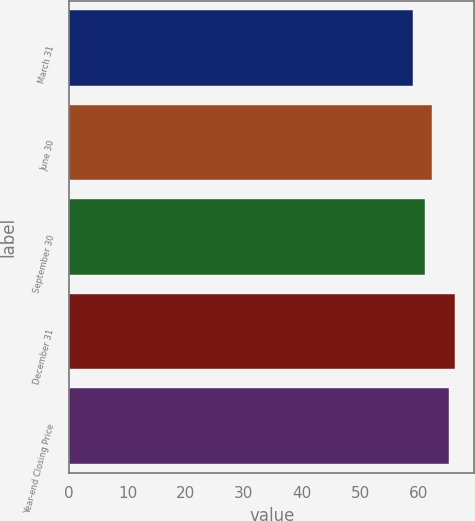Convert chart. <chart><loc_0><loc_0><loc_500><loc_500><bar_chart><fcel>March 31<fcel>June 30<fcel>September 30<fcel>December 31<fcel>Year-end Closing Price<nl><fcel>59.02<fcel>62.38<fcel>61.19<fcel>66.26<fcel>65.21<nl></chart> 